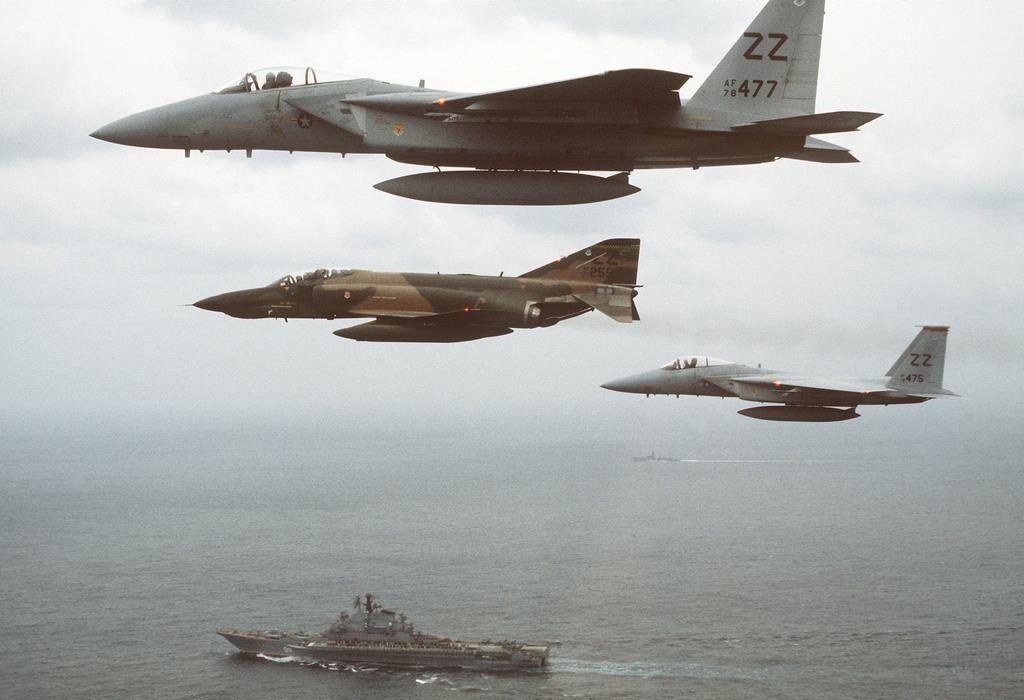Could you give a brief overview of what you see in this image? In this image we can see there are airplanes flying in the sky, there is a ship in the water, the sky is cloudy. 